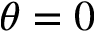<formula> <loc_0><loc_0><loc_500><loc_500>\theta = 0</formula> 